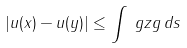Convert formula to latex. <formula><loc_0><loc_0><loc_500><loc_500>| u ( x ) - u ( y ) | \leq \int _ { \ } g z g \, d s</formula> 